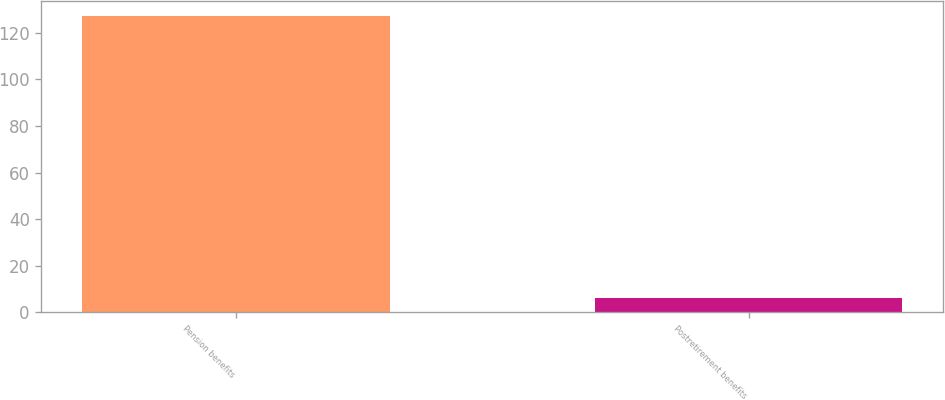Convert chart. <chart><loc_0><loc_0><loc_500><loc_500><bar_chart><fcel>Pension benefits<fcel>Postretirement benefits<nl><fcel>127.3<fcel>6.3<nl></chart> 